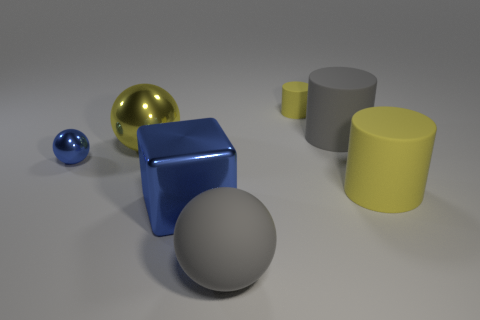There is a gray thing in front of the metallic block; does it have the same size as the small blue metal sphere?
Provide a short and direct response. No. There is a small yellow rubber object; how many large metal objects are in front of it?
Provide a succinct answer. 2. There is a object that is both behind the small blue ball and left of the shiny cube; what is its material?
Provide a succinct answer. Metal. How many small things are either balls or yellow cylinders?
Your answer should be very brief. 2. How big is the blue cube?
Ensure brevity in your answer.  Large. What shape is the small blue object?
Keep it short and to the point. Sphere. Is there anything else that has the same shape as the big blue metal thing?
Provide a succinct answer. No. Are there fewer gray objects that are to the right of the gray sphere than purple metallic balls?
Ensure brevity in your answer.  No. There is a shiny thing in front of the large yellow rubber object; is its color the same as the tiny metallic thing?
Keep it short and to the point. Yes. How many matte things are either big cyan objects or tiny blue objects?
Provide a succinct answer. 0. 